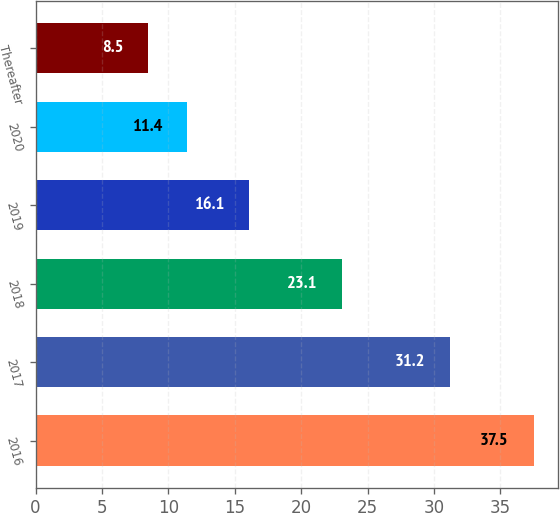Convert chart to OTSL. <chart><loc_0><loc_0><loc_500><loc_500><bar_chart><fcel>2016<fcel>2017<fcel>2018<fcel>2019<fcel>2020<fcel>Thereafter<nl><fcel>37.5<fcel>31.2<fcel>23.1<fcel>16.1<fcel>11.4<fcel>8.5<nl></chart> 